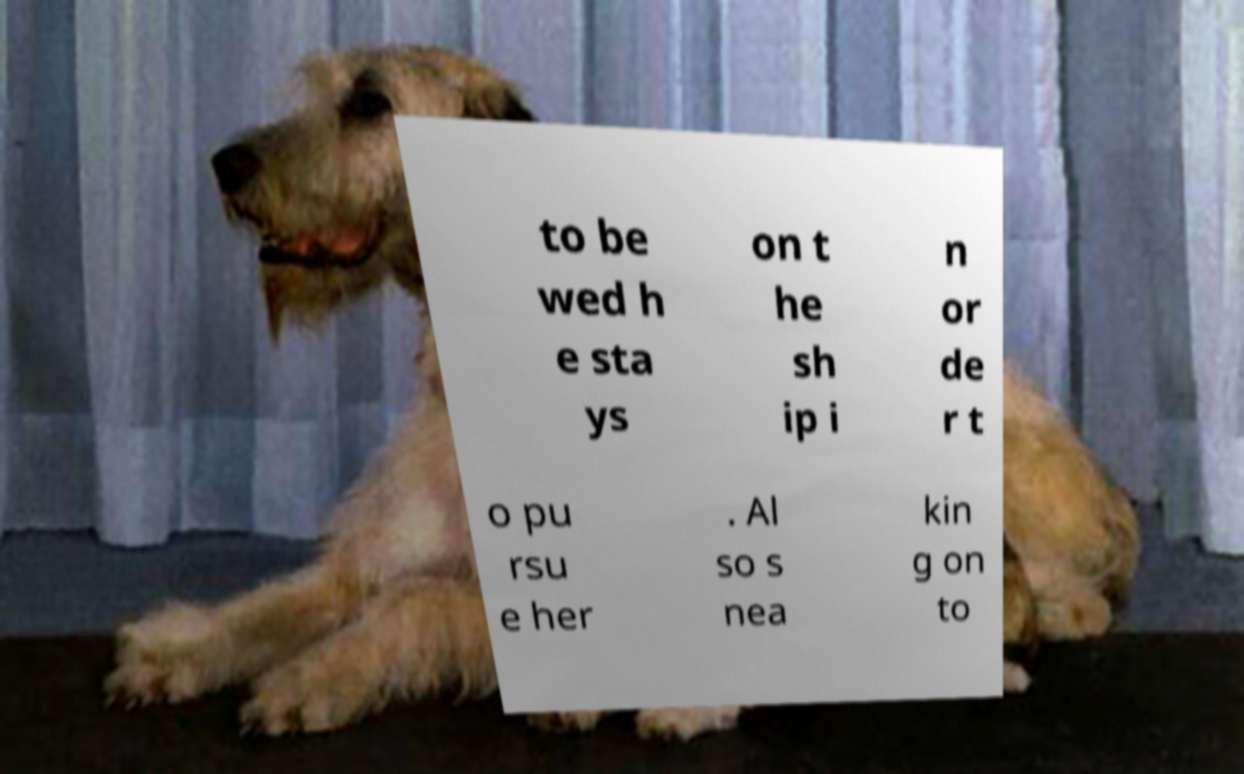Can you accurately transcribe the text from the provided image for me? to be wed h e sta ys on t he sh ip i n or de r t o pu rsu e her . Al so s nea kin g on to 